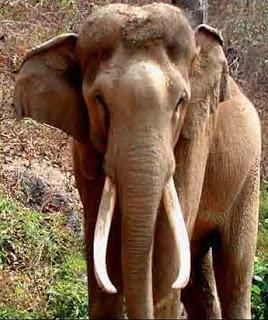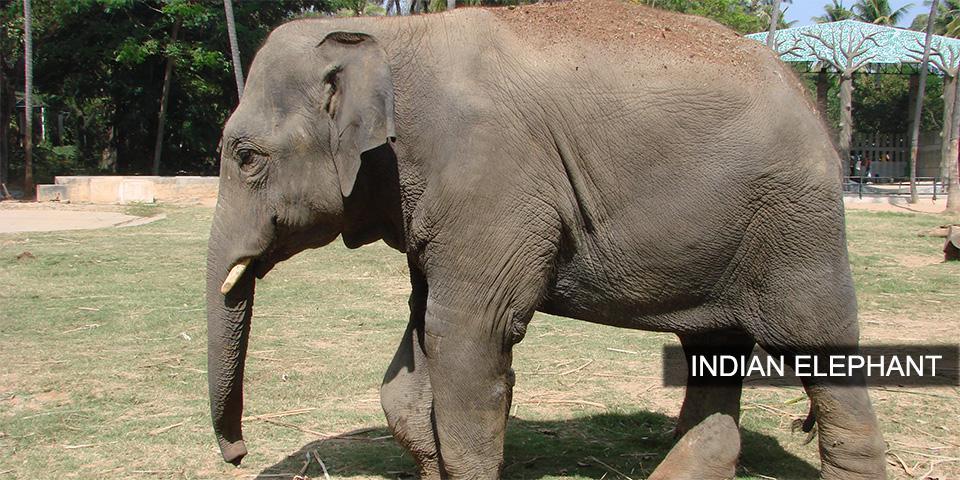The first image is the image on the left, the second image is the image on the right. Given the left and right images, does the statement "Each image shows a single elephant, and all elephants have tusks." hold true? Answer yes or no. Yes. The first image is the image on the left, the second image is the image on the right. Assess this claim about the two images: "At least one of the elephants does not have tusks.". Correct or not? Answer yes or no. No. 